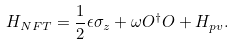<formula> <loc_0><loc_0><loc_500><loc_500>H _ { N F T } = \frac { 1 } { 2 } \epsilon \sigma _ { z } + \omega O ^ { \dagger } O + H _ { p v } .</formula> 